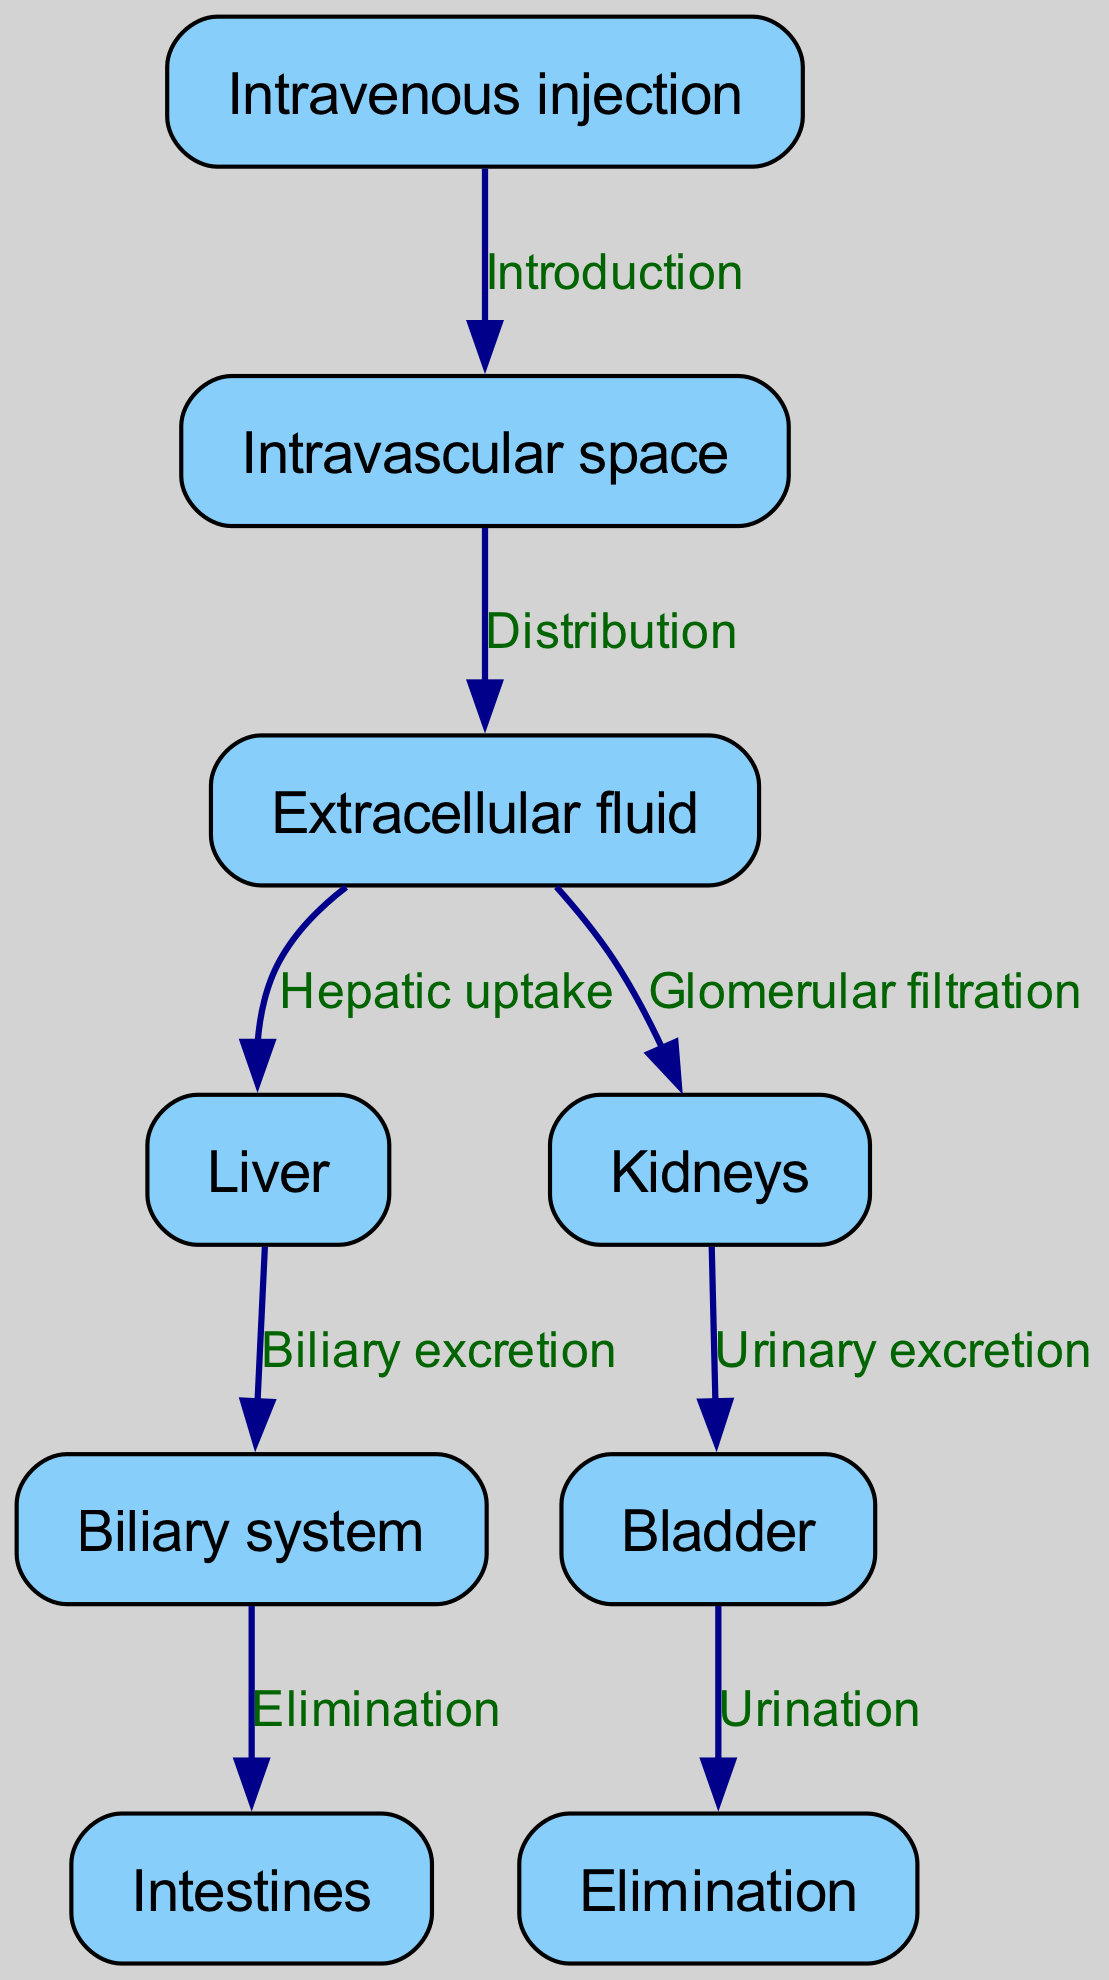What is the first step in the contrast agent metabolism process? The first step in the diagram is "Intravenous injection," where the contrast agent is introduced into the body.
Answer: Intravenous injection How many nodes are present in the diagram? The diagram features a total of eight nodes that represent different stages and locations in the metabolism and excretion process.
Answer: 8 What kind of excretion occurs after the kidneys? The edge labeled "Urinary excretion" indicates that after the kidneys, the process leads to the bladder for urinary excretion.
Answer: Urinary excretion Which organ is involved in biliary excretion? The edge directed from "Liver" to "Biliary system" in the diagram demonstrates that the liver is responsible for biliary excretion.
Answer: Liver What follows after the biliary system in the process? The diagram shows that after the biliary system, the contrast agent proceeds to the intestines, as indicated by the edge labeled "Elimination."
Answer: Intestines What is the relationship between the intravascular space and extracellular fluid? The relationship is shown by the edge labeled "Distribution," which indicates that the intravascular space allows for the distribution of the agent into the extracellular fluid.
Answer: Distribution How does the contrast agent reach the bladder? The diagram illustrates that the contrast agent is filtered through the kidneys, leading to the bladder as indicated by the edge labeled "Urinary excretion."
Answer: Filtered through kidneys Which organ is the last to process the contrast agent before elimination? The diagram indicates that the intestines are the last organ mentioned before the elimination of the contrast agent through the biliary path.
Answer: Intestines 